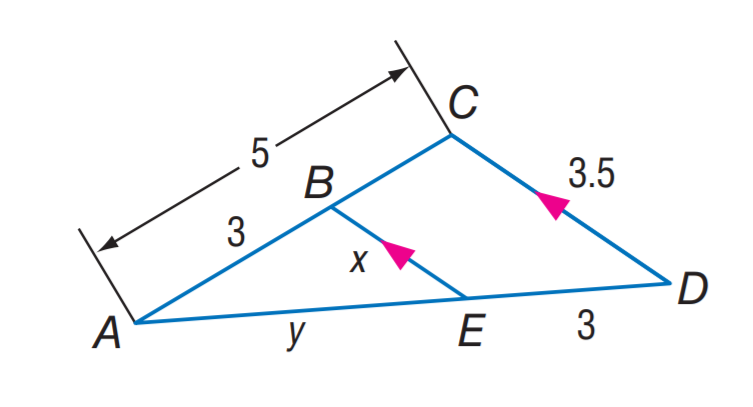Answer the mathemtical geometry problem and directly provide the correct option letter.
Question: Find B E.
Choices: A: 2.1 B: 2.5 C: 3.1 D: 3.5 A 